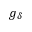Convert formula to latex. <formula><loc_0><loc_0><loc_500><loc_500>g _ { \delta }</formula> 